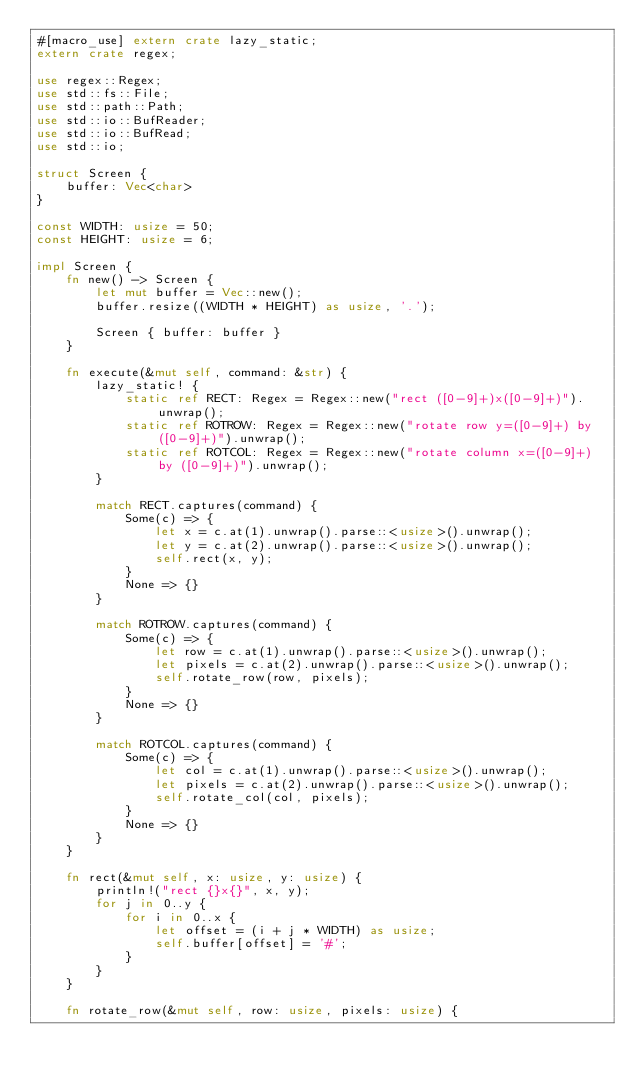Convert code to text. <code><loc_0><loc_0><loc_500><loc_500><_Rust_>#[macro_use] extern crate lazy_static;
extern crate regex;

use regex::Regex;
use std::fs::File;
use std::path::Path;
use std::io::BufReader;
use std::io::BufRead;
use std::io;

struct Screen {
    buffer: Vec<char>
}

const WIDTH: usize = 50;
const HEIGHT: usize = 6;

impl Screen {
    fn new() -> Screen {
        let mut buffer = Vec::new();
        buffer.resize((WIDTH * HEIGHT) as usize, '.');

        Screen { buffer: buffer }
    }

    fn execute(&mut self, command: &str) {
        lazy_static! {
            static ref RECT: Regex = Regex::new("rect ([0-9]+)x([0-9]+)").unwrap();
            static ref ROTROW: Regex = Regex::new("rotate row y=([0-9]+) by ([0-9]+)").unwrap();
            static ref ROTCOL: Regex = Regex::new("rotate column x=([0-9]+) by ([0-9]+)").unwrap();
        }

        match RECT.captures(command) {
            Some(c) => {
                let x = c.at(1).unwrap().parse::<usize>().unwrap();
                let y = c.at(2).unwrap().parse::<usize>().unwrap();
                self.rect(x, y);
            }
            None => {}
        }

        match ROTROW.captures(command) {
            Some(c) => {
                let row = c.at(1).unwrap().parse::<usize>().unwrap();
                let pixels = c.at(2).unwrap().parse::<usize>().unwrap();
                self.rotate_row(row, pixels);
            }
            None => {}
        }

        match ROTCOL.captures(command) {
            Some(c) => {
                let col = c.at(1).unwrap().parse::<usize>().unwrap();
                let pixels = c.at(2).unwrap().parse::<usize>().unwrap();
                self.rotate_col(col, pixels);
            }
            None => {}
        }
    }

    fn rect(&mut self, x: usize, y: usize) {
        println!("rect {}x{}", x, y);
        for j in 0..y {
            for i in 0..x {
                let offset = (i + j * WIDTH) as usize;
                self.buffer[offset] = '#';
            }
        }
    }

    fn rotate_row(&mut self, row: usize, pixels: usize) {</code> 